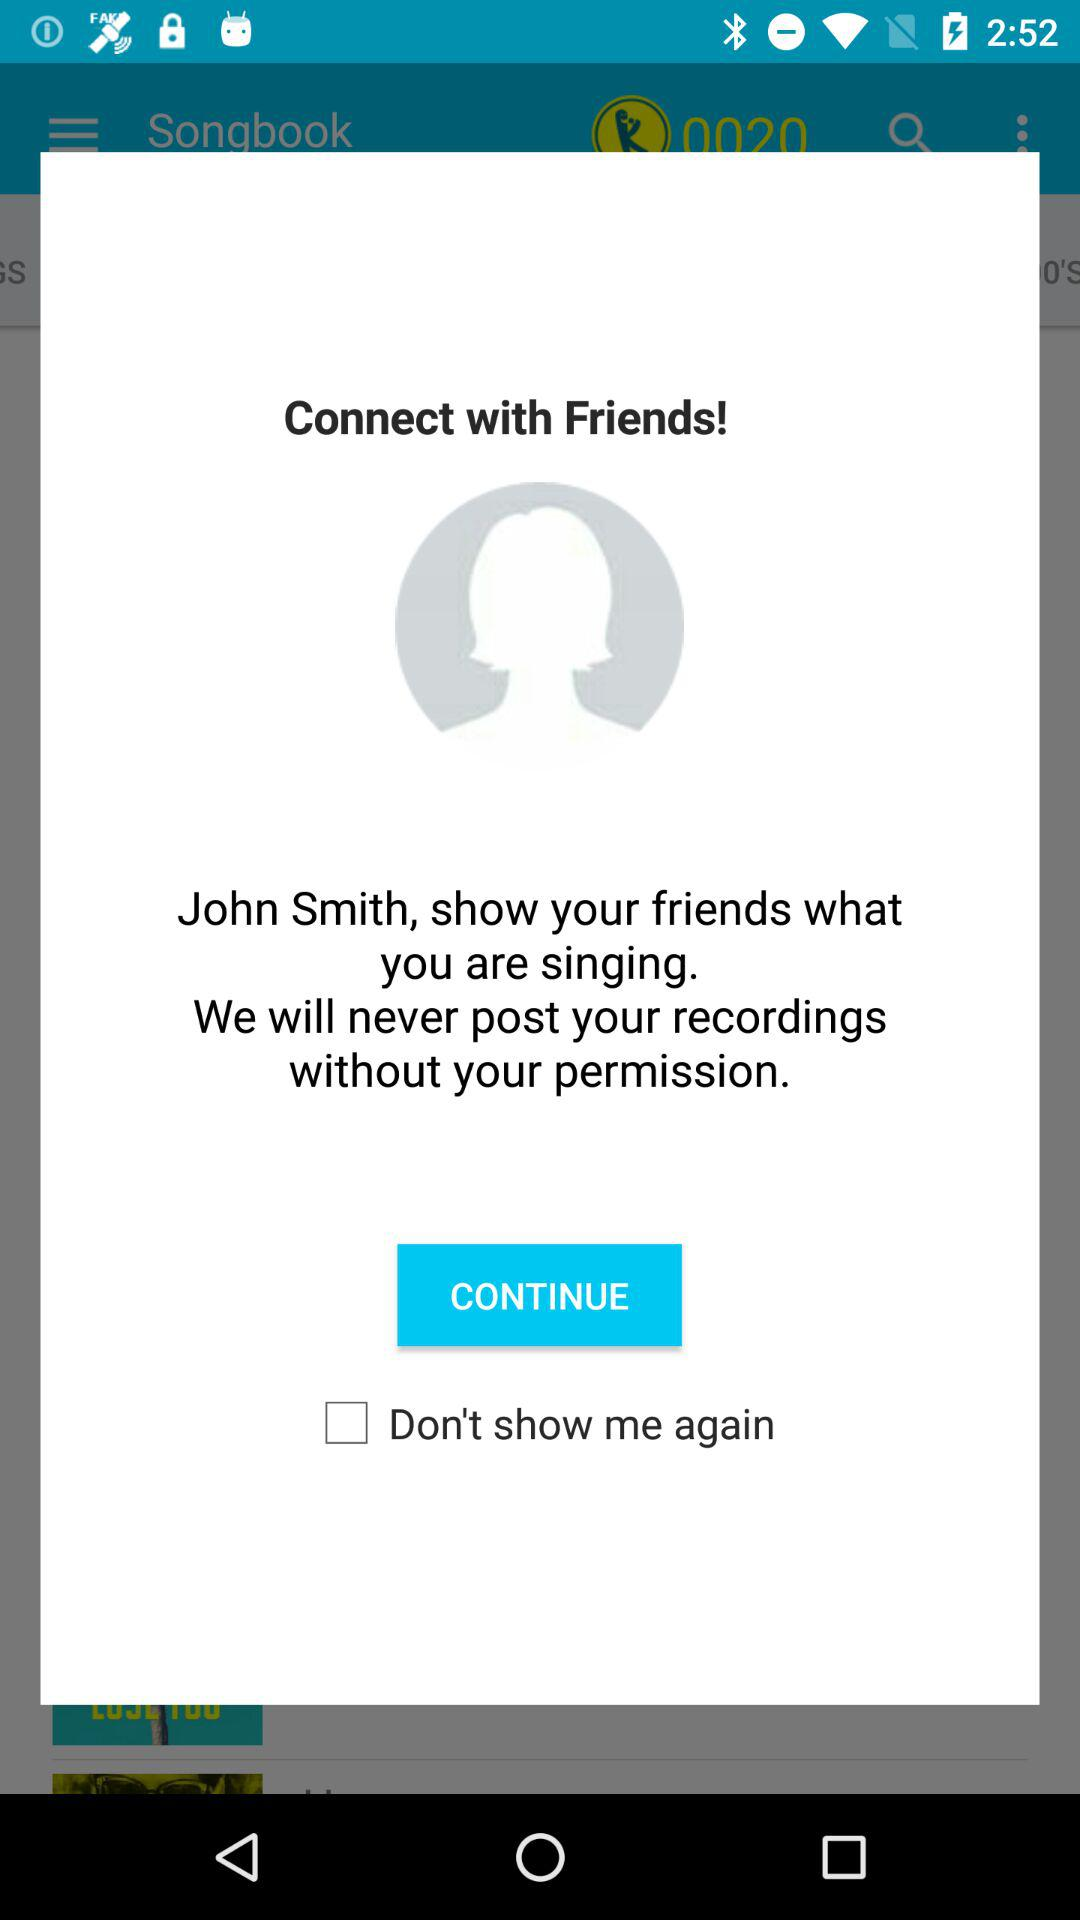What is the status of "Don't show me again"? The status of "Don't show me again" is "off". 